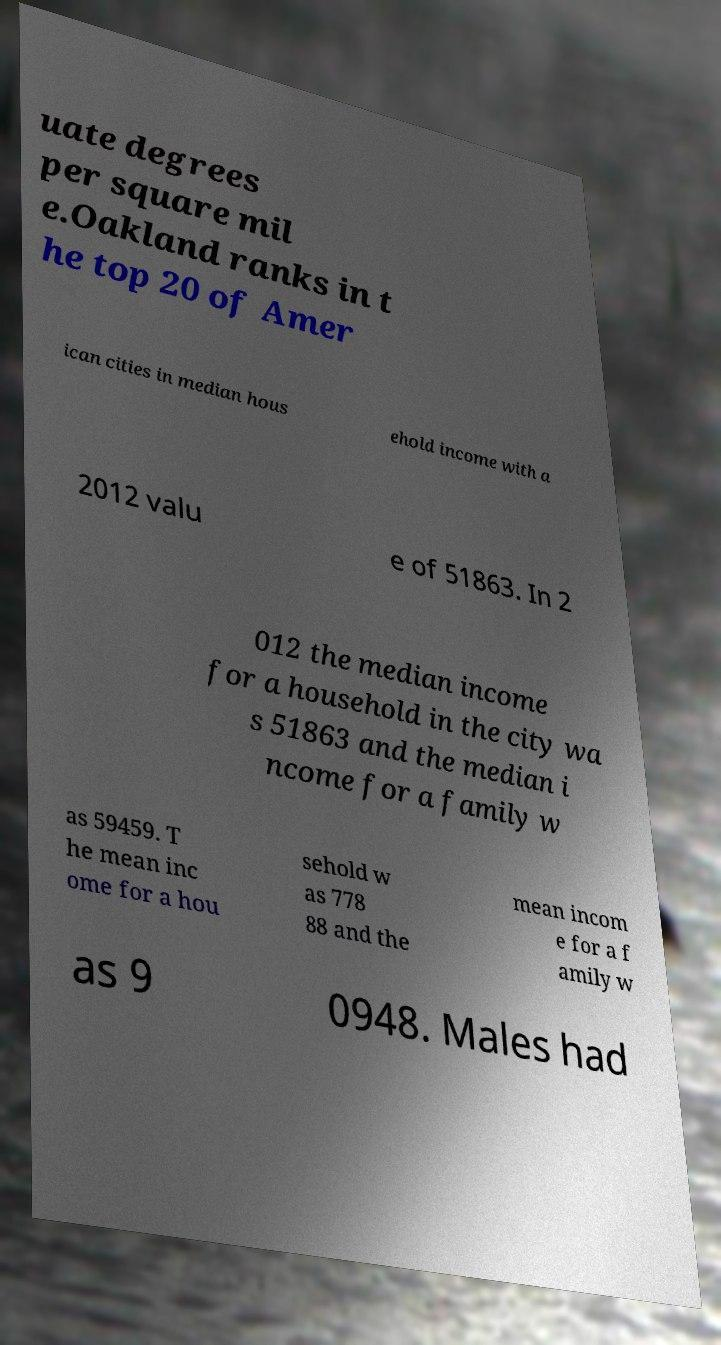Please read and relay the text visible in this image. What does it say? uate degrees per square mil e.Oakland ranks in t he top 20 of Amer ican cities in median hous ehold income with a 2012 valu e of 51863. In 2 012 the median income for a household in the city wa s 51863 and the median i ncome for a family w as 59459. T he mean inc ome for a hou sehold w as 778 88 and the mean incom e for a f amily w as 9 0948. Males had 